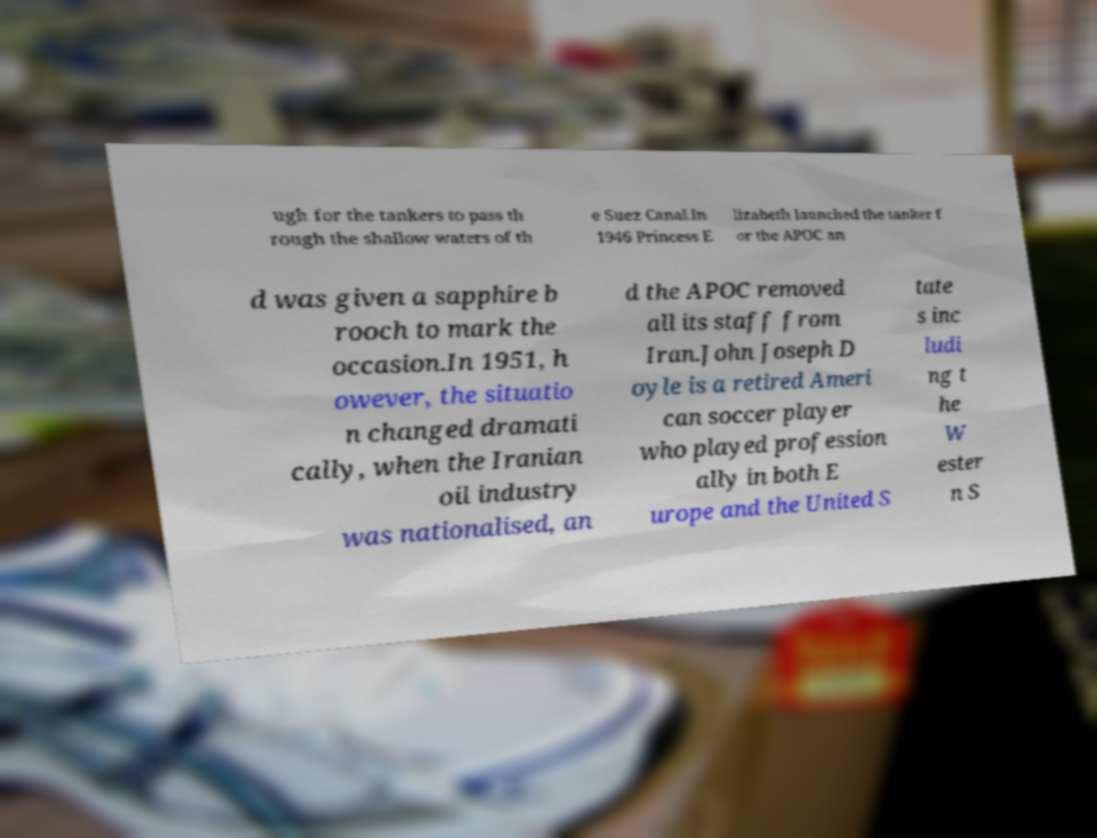I need the written content from this picture converted into text. Can you do that? ugh for the tankers to pass th rough the shallow waters of th e Suez Canal.In 1946 Princess E lizabeth launched the tanker f or the APOC an d was given a sapphire b rooch to mark the occasion.In 1951, h owever, the situatio n changed dramati cally, when the Iranian oil industry was nationalised, an d the APOC removed all its staff from Iran.John Joseph D oyle is a retired Ameri can soccer player who played profession ally in both E urope and the United S tate s inc ludi ng t he W ester n S 